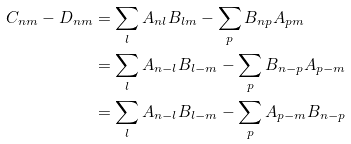<formula> <loc_0><loc_0><loc_500><loc_500>C _ { n m } - D _ { n m } & = \sum _ { l } { A _ { n l } B _ { l m } } - \sum _ { p } { B _ { n p } A _ { p m } } \\ & = \sum _ { l } { A _ { n - l } B _ { l - m } } - \sum _ { p } { B _ { n - p } A _ { p - m } } \\ & = \sum _ { l } { A _ { n - l } B _ { l - m } } - \sum _ { p } { A _ { p - m } B _ { n - p } } \\</formula> 